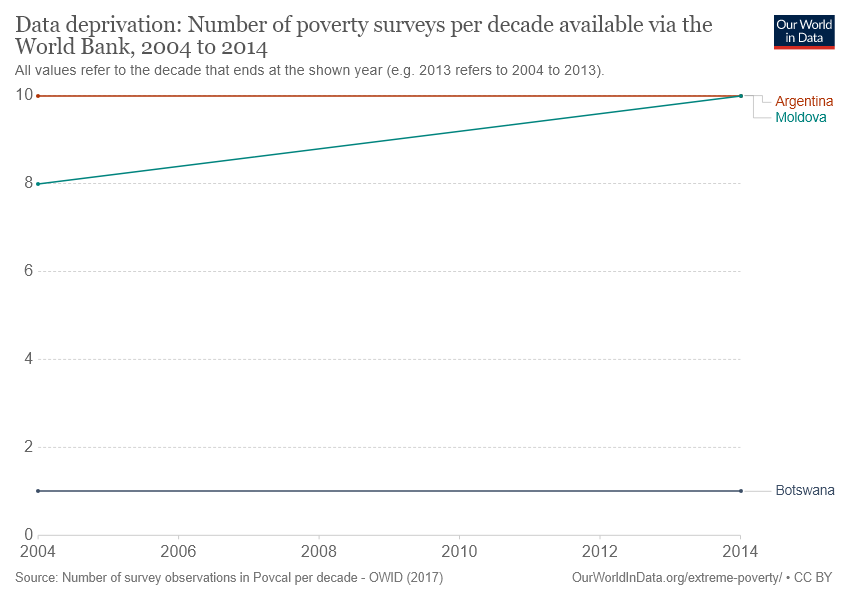Draw attention to some important aspects in this diagram. In 2014, the highest number of poverty surveys was recorded in Moldova. The red color line in the given graph represents Argentina. 